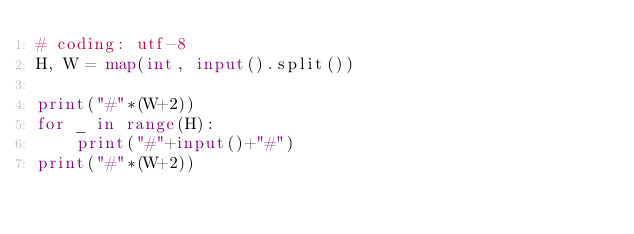Convert code to text. <code><loc_0><loc_0><loc_500><loc_500><_Python_># coding: utf-8
H, W = map(int, input().split())

print("#"*(W+2))
for _ in range(H):
    print("#"+input()+"#")
print("#"*(W+2))</code> 